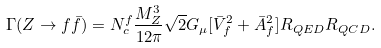Convert formula to latex. <formula><loc_0><loc_0><loc_500><loc_500>\Gamma ( Z \rightarrow f \bar { f } ) = N _ { c } ^ { f } \frac { M _ { Z } ^ { 3 } } { 1 2 \pi } \sqrt { 2 } G _ { \mu } [ \bar { V } _ { f } ^ { 2 } + \bar { A } _ { f } ^ { 2 } ] R _ { Q E D } R _ { Q C D } .</formula> 